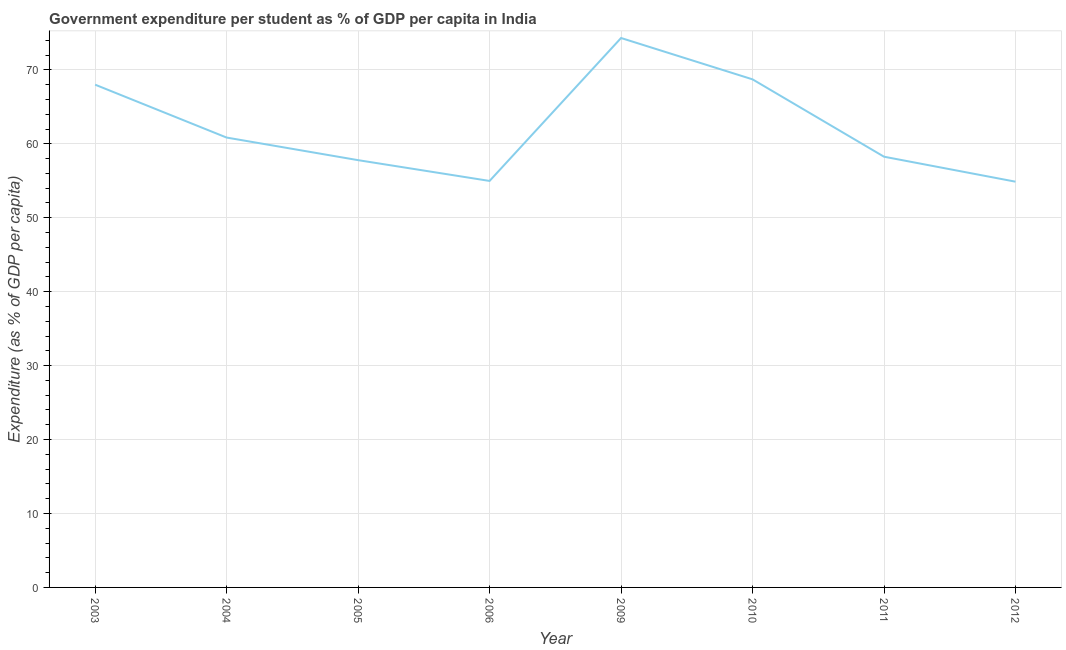What is the government expenditure per student in 2005?
Offer a very short reply. 57.79. Across all years, what is the maximum government expenditure per student?
Offer a very short reply. 74.31. Across all years, what is the minimum government expenditure per student?
Make the answer very short. 54.88. In which year was the government expenditure per student maximum?
Ensure brevity in your answer.  2009. What is the sum of the government expenditure per student?
Keep it short and to the point. 497.78. What is the difference between the government expenditure per student in 2006 and 2012?
Keep it short and to the point. 0.1. What is the average government expenditure per student per year?
Provide a succinct answer. 62.22. What is the median government expenditure per student?
Offer a very short reply. 59.55. What is the ratio of the government expenditure per student in 2004 to that in 2011?
Provide a short and direct response. 1.04. Is the difference between the government expenditure per student in 2006 and 2010 greater than the difference between any two years?
Your answer should be very brief. No. What is the difference between the highest and the second highest government expenditure per student?
Make the answer very short. 5.59. Is the sum of the government expenditure per student in 2005 and 2009 greater than the maximum government expenditure per student across all years?
Offer a very short reply. Yes. What is the difference between the highest and the lowest government expenditure per student?
Keep it short and to the point. 19.43. In how many years, is the government expenditure per student greater than the average government expenditure per student taken over all years?
Offer a terse response. 3. Does the government expenditure per student monotonically increase over the years?
Provide a succinct answer. No. What is the difference between two consecutive major ticks on the Y-axis?
Your response must be concise. 10. Does the graph contain any zero values?
Your answer should be compact. No. Does the graph contain grids?
Your answer should be compact. Yes. What is the title of the graph?
Ensure brevity in your answer.  Government expenditure per student as % of GDP per capita in India. What is the label or title of the Y-axis?
Offer a terse response. Expenditure (as % of GDP per capita). What is the Expenditure (as % of GDP per capita) in 2003?
Give a very brief answer. 68. What is the Expenditure (as % of GDP per capita) in 2004?
Your answer should be very brief. 60.85. What is the Expenditure (as % of GDP per capita) in 2005?
Your answer should be compact. 57.79. What is the Expenditure (as % of GDP per capita) of 2006?
Provide a succinct answer. 54.98. What is the Expenditure (as % of GDP per capita) in 2009?
Offer a terse response. 74.31. What is the Expenditure (as % of GDP per capita) of 2010?
Give a very brief answer. 68.72. What is the Expenditure (as % of GDP per capita) in 2011?
Provide a short and direct response. 58.26. What is the Expenditure (as % of GDP per capita) in 2012?
Give a very brief answer. 54.88. What is the difference between the Expenditure (as % of GDP per capita) in 2003 and 2004?
Your response must be concise. 7.15. What is the difference between the Expenditure (as % of GDP per capita) in 2003 and 2005?
Keep it short and to the point. 10.21. What is the difference between the Expenditure (as % of GDP per capita) in 2003 and 2006?
Offer a very short reply. 13.02. What is the difference between the Expenditure (as % of GDP per capita) in 2003 and 2009?
Provide a short and direct response. -6.31. What is the difference between the Expenditure (as % of GDP per capita) in 2003 and 2010?
Your answer should be very brief. -0.72. What is the difference between the Expenditure (as % of GDP per capita) in 2003 and 2011?
Give a very brief answer. 9.74. What is the difference between the Expenditure (as % of GDP per capita) in 2003 and 2012?
Provide a short and direct response. 13.12. What is the difference between the Expenditure (as % of GDP per capita) in 2004 and 2005?
Provide a succinct answer. 3.06. What is the difference between the Expenditure (as % of GDP per capita) in 2004 and 2006?
Ensure brevity in your answer.  5.87. What is the difference between the Expenditure (as % of GDP per capita) in 2004 and 2009?
Keep it short and to the point. -13.47. What is the difference between the Expenditure (as % of GDP per capita) in 2004 and 2010?
Your response must be concise. -7.87. What is the difference between the Expenditure (as % of GDP per capita) in 2004 and 2011?
Provide a succinct answer. 2.59. What is the difference between the Expenditure (as % of GDP per capita) in 2004 and 2012?
Your response must be concise. 5.97. What is the difference between the Expenditure (as % of GDP per capita) in 2005 and 2006?
Give a very brief answer. 2.81. What is the difference between the Expenditure (as % of GDP per capita) in 2005 and 2009?
Offer a very short reply. -16.52. What is the difference between the Expenditure (as % of GDP per capita) in 2005 and 2010?
Offer a very short reply. -10.93. What is the difference between the Expenditure (as % of GDP per capita) in 2005 and 2011?
Offer a terse response. -0.47. What is the difference between the Expenditure (as % of GDP per capita) in 2005 and 2012?
Provide a succinct answer. 2.91. What is the difference between the Expenditure (as % of GDP per capita) in 2006 and 2009?
Give a very brief answer. -19.33. What is the difference between the Expenditure (as % of GDP per capita) in 2006 and 2010?
Keep it short and to the point. -13.74. What is the difference between the Expenditure (as % of GDP per capita) in 2006 and 2011?
Your answer should be compact. -3.28. What is the difference between the Expenditure (as % of GDP per capita) in 2006 and 2012?
Offer a terse response. 0.1. What is the difference between the Expenditure (as % of GDP per capita) in 2009 and 2010?
Make the answer very short. 5.59. What is the difference between the Expenditure (as % of GDP per capita) in 2009 and 2011?
Your answer should be compact. 16.05. What is the difference between the Expenditure (as % of GDP per capita) in 2009 and 2012?
Your response must be concise. 19.43. What is the difference between the Expenditure (as % of GDP per capita) in 2010 and 2011?
Provide a short and direct response. 10.46. What is the difference between the Expenditure (as % of GDP per capita) in 2010 and 2012?
Offer a very short reply. 13.84. What is the difference between the Expenditure (as % of GDP per capita) in 2011 and 2012?
Offer a terse response. 3.38. What is the ratio of the Expenditure (as % of GDP per capita) in 2003 to that in 2004?
Your response must be concise. 1.12. What is the ratio of the Expenditure (as % of GDP per capita) in 2003 to that in 2005?
Offer a very short reply. 1.18. What is the ratio of the Expenditure (as % of GDP per capita) in 2003 to that in 2006?
Provide a short and direct response. 1.24. What is the ratio of the Expenditure (as % of GDP per capita) in 2003 to that in 2009?
Your response must be concise. 0.92. What is the ratio of the Expenditure (as % of GDP per capita) in 2003 to that in 2010?
Your response must be concise. 0.99. What is the ratio of the Expenditure (as % of GDP per capita) in 2003 to that in 2011?
Keep it short and to the point. 1.17. What is the ratio of the Expenditure (as % of GDP per capita) in 2003 to that in 2012?
Provide a succinct answer. 1.24. What is the ratio of the Expenditure (as % of GDP per capita) in 2004 to that in 2005?
Give a very brief answer. 1.05. What is the ratio of the Expenditure (as % of GDP per capita) in 2004 to that in 2006?
Your answer should be compact. 1.11. What is the ratio of the Expenditure (as % of GDP per capita) in 2004 to that in 2009?
Provide a short and direct response. 0.82. What is the ratio of the Expenditure (as % of GDP per capita) in 2004 to that in 2010?
Your answer should be compact. 0.89. What is the ratio of the Expenditure (as % of GDP per capita) in 2004 to that in 2011?
Your response must be concise. 1.04. What is the ratio of the Expenditure (as % of GDP per capita) in 2004 to that in 2012?
Your response must be concise. 1.11. What is the ratio of the Expenditure (as % of GDP per capita) in 2005 to that in 2006?
Offer a very short reply. 1.05. What is the ratio of the Expenditure (as % of GDP per capita) in 2005 to that in 2009?
Provide a short and direct response. 0.78. What is the ratio of the Expenditure (as % of GDP per capita) in 2005 to that in 2010?
Your response must be concise. 0.84. What is the ratio of the Expenditure (as % of GDP per capita) in 2005 to that in 2012?
Your response must be concise. 1.05. What is the ratio of the Expenditure (as % of GDP per capita) in 2006 to that in 2009?
Ensure brevity in your answer.  0.74. What is the ratio of the Expenditure (as % of GDP per capita) in 2006 to that in 2010?
Your answer should be very brief. 0.8. What is the ratio of the Expenditure (as % of GDP per capita) in 2006 to that in 2011?
Provide a succinct answer. 0.94. What is the ratio of the Expenditure (as % of GDP per capita) in 2009 to that in 2010?
Your response must be concise. 1.08. What is the ratio of the Expenditure (as % of GDP per capita) in 2009 to that in 2011?
Give a very brief answer. 1.28. What is the ratio of the Expenditure (as % of GDP per capita) in 2009 to that in 2012?
Ensure brevity in your answer.  1.35. What is the ratio of the Expenditure (as % of GDP per capita) in 2010 to that in 2011?
Provide a short and direct response. 1.18. What is the ratio of the Expenditure (as % of GDP per capita) in 2010 to that in 2012?
Provide a succinct answer. 1.25. What is the ratio of the Expenditure (as % of GDP per capita) in 2011 to that in 2012?
Provide a succinct answer. 1.06. 